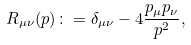Convert formula to latex. <formula><loc_0><loc_0><loc_500><loc_500>R _ { \mu \nu } ( p ) \colon = \delta _ { \mu \nu } - 4 { \frac { p _ { \mu } p _ { \nu } } { p ^ { 2 } } } ,</formula> 